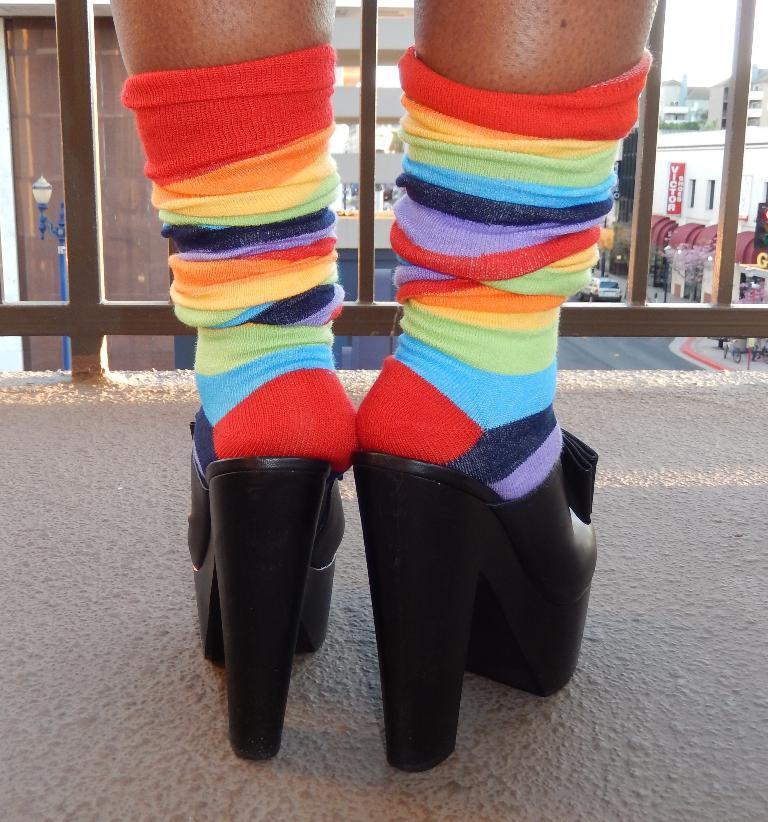Please provide a concise description of this image. In the center of the image there is a platform. On the platform, we can see the legs of a person with heels and socks. In front of legs, there is a fence. In the background, we can see buildings and a few other objects. 